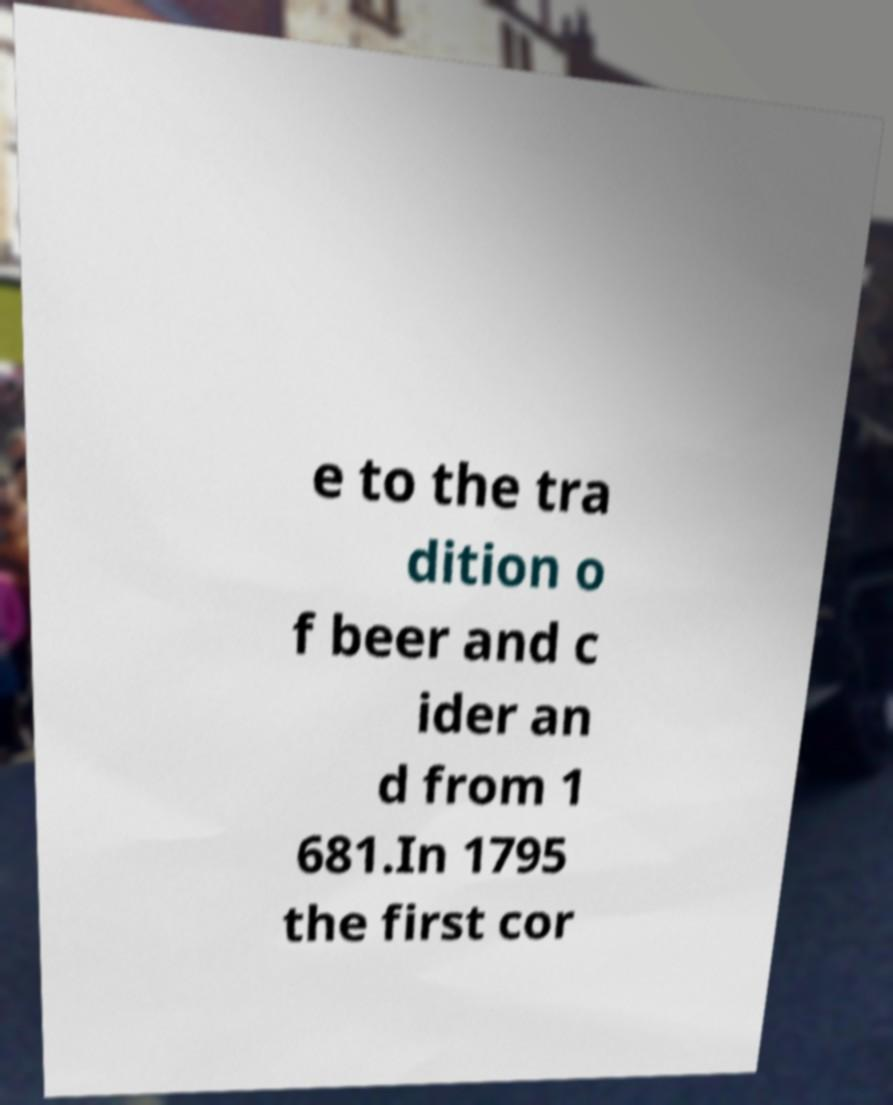For documentation purposes, I need the text within this image transcribed. Could you provide that? e to the tra dition o f beer and c ider an d from 1 681.In 1795 the first cor 